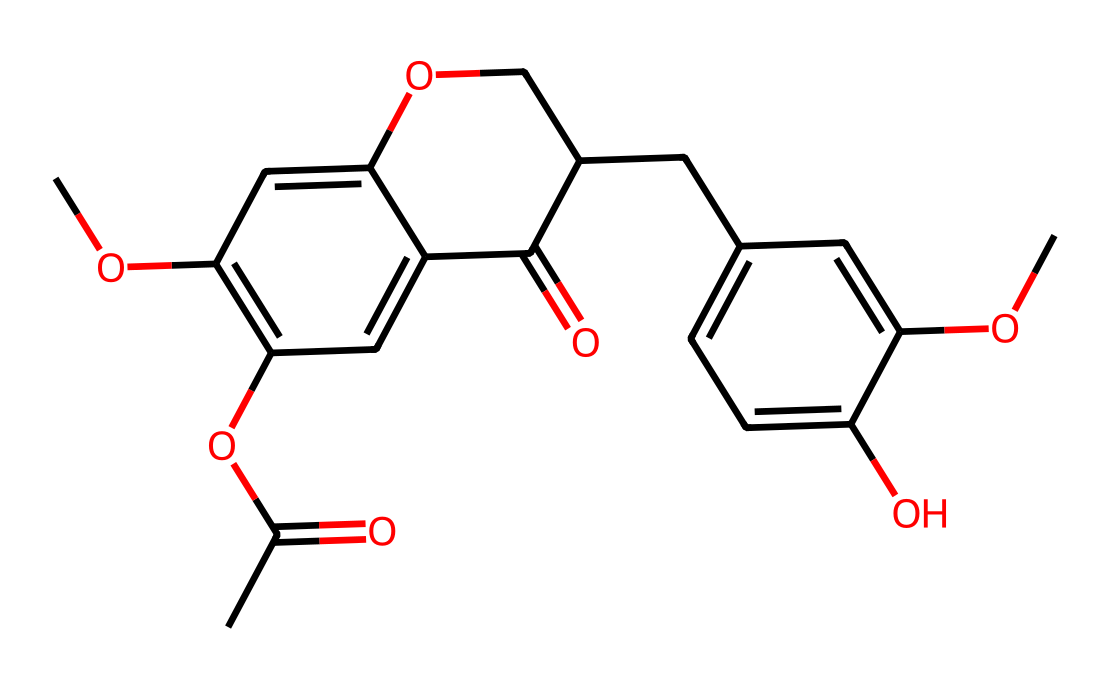What is the total number of carbon atoms in this molecule? By analyzing the SMILES representation, we can count each carbon (C) atom listed. There are 18 occurrences of carbon in the chemical structure.
Answer: 18 How many ketone functional groups are present in this molecule? In the SMILES, the ketone functional group is identified by the carbonyl (C=O) structure connected to a carbon atom. This molecule contains two of these structures.
Answer: 2 What type of compound is represented by this molecular structure? The presence of the ketone functional groups and the other functional groups suggests this molecule is a complex organic compound, specifically categorized as a ketone.
Answer: ketone Which part of this chemical structure indicates the presence of an ether? The "OC" part in the SMILES indicates an ether group, where an oxygen atom is bonded to two carbon atoms, signifying the ether functional group in the structure.
Answer: OC What is the degree of unsaturation for this chemical? To calculate the degree of unsaturation, we use the formula: Degree of Unsaturation = 1 + (2n + 2 - x)/2, where n is the number of carbons and x is the number of hydrogens in the molecular structure. Given the structure, a rough calculation yields a degree of unsaturation of 6.
Answer: 6 